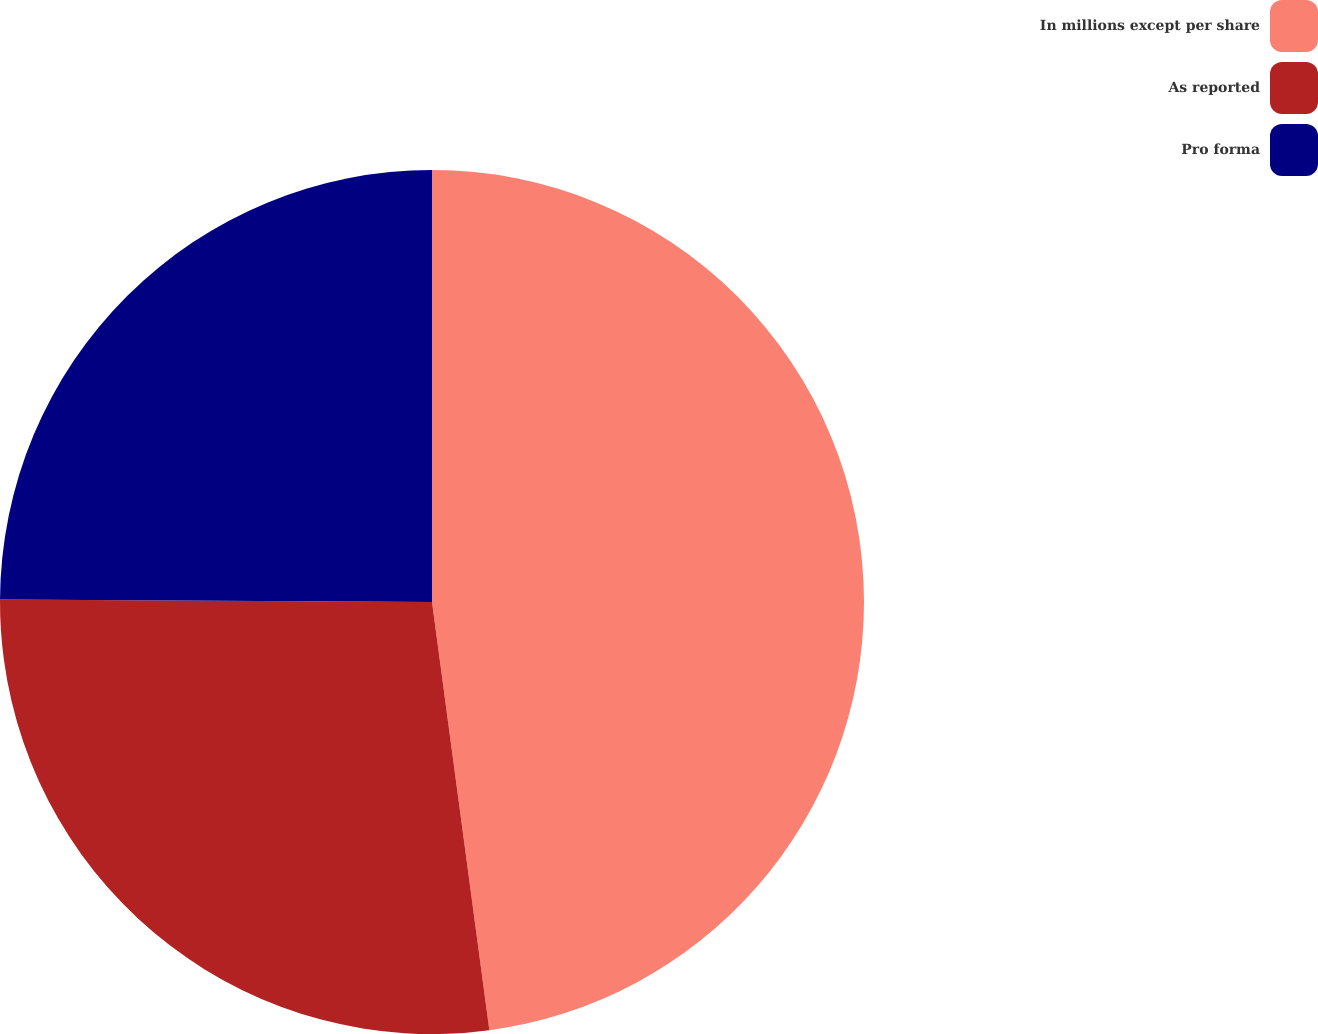<chart> <loc_0><loc_0><loc_500><loc_500><pie_chart><fcel>In millions except per share<fcel>As reported<fcel>Pro forma<nl><fcel>47.88%<fcel>27.21%<fcel>24.91%<nl></chart> 